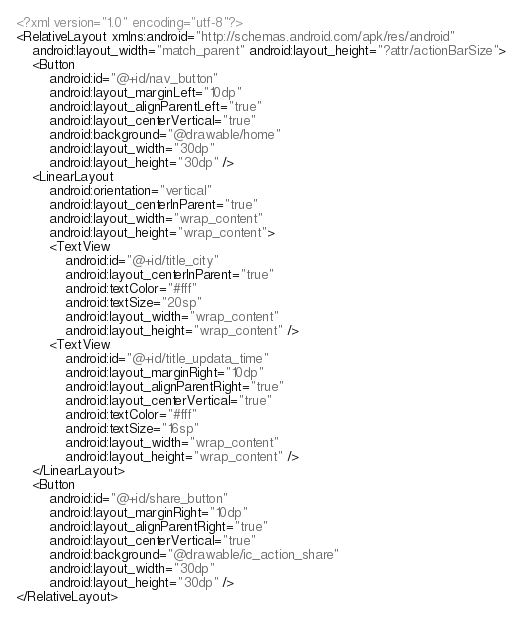Convert code to text. <code><loc_0><loc_0><loc_500><loc_500><_XML_><?xml version="1.0" encoding="utf-8"?>
<RelativeLayout xmlns:android="http://schemas.android.com/apk/res/android"
    android:layout_width="match_parent" android:layout_height="?attr/actionBarSize">
    <Button
        android:id="@+id/nav_button"
        android:layout_marginLeft="10dp"
        android:layout_alignParentLeft="true"
        android:layout_centerVertical="true"
        android:background="@drawable/home"
        android:layout_width="30dp"
        android:layout_height="30dp" />
    <LinearLayout
        android:orientation="vertical"
        android:layout_centerInParent="true"
        android:layout_width="wrap_content"
        android:layout_height="wrap_content">
        <TextView
            android:id="@+id/title_city"
            android:layout_centerInParent="true"
            android:textColor="#fff"
            android:textSize="20sp"
            android:layout_width="wrap_content"
            android:layout_height="wrap_content" />
        <TextView
            android:id="@+id/title_updata_time"
            android:layout_marginRight="10dp"
            android:layout_alignParentRight="true"
            android:layout_centerVertical="true"
            android:textColor="#fff"
            android:textSize="16sp"
            android:layout_width="wrap_content"
            android:layout_height="wrap_content" />
    </LinearLayout>
    <Button
        android:id="@+id/share_button"
        android:layout_marginRight="10dp"
        android:layout_alignParentRight="true"
        android:layout_centerVertical="true"
        android:background="@drawable/ic_action_share"
        android:layout_width="30dp"
        android:layout_height="30dp" />
</RelativeLayout></code> 